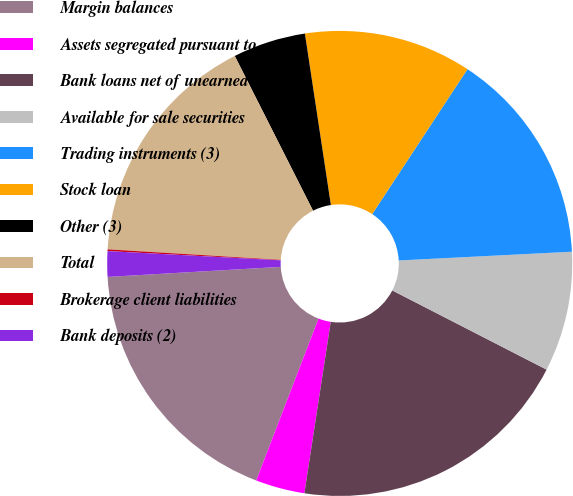<chart> <loc_0><loc_0><loc_500><loc_500><pie_chart><fcel>Margin balances<fcel>Assets segregated pursuant to<fcel>Bank loans net of unearned<fcel>Available for sale securities<fcel>Trading instruments (3)<fcel>Stock loan<fcel>Other (3)<fcel>Total<fcel>Brokerage client liabilities<fcel>Bank deposits (2)<nl><fcel>18.23%<fcel>3.42%<fcel>19.88%<fcel>8.35%<fcel>14.94%<fcel>11.65%<fcel>5.06%<fcel>16.58%<fcel>0.12%<fcel>1.77%<nl></chart> 